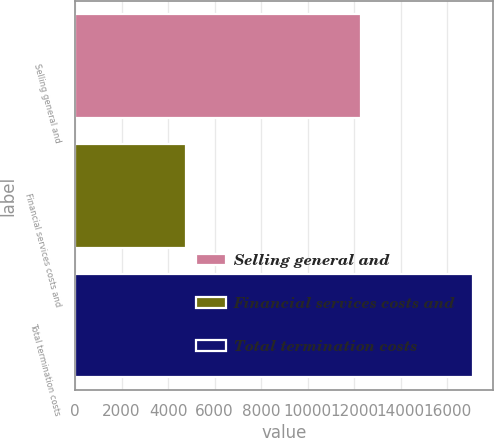Convert chart to OTSL. <chart><loc_0><loc_0><loc_500><loc_500><bar_chart><fcel>Selling general and<fcel>Financial services costs and<fcel>Total termination costs<nl><fcel>12305<fcel>4789<fcel>17094<nl></chart> 